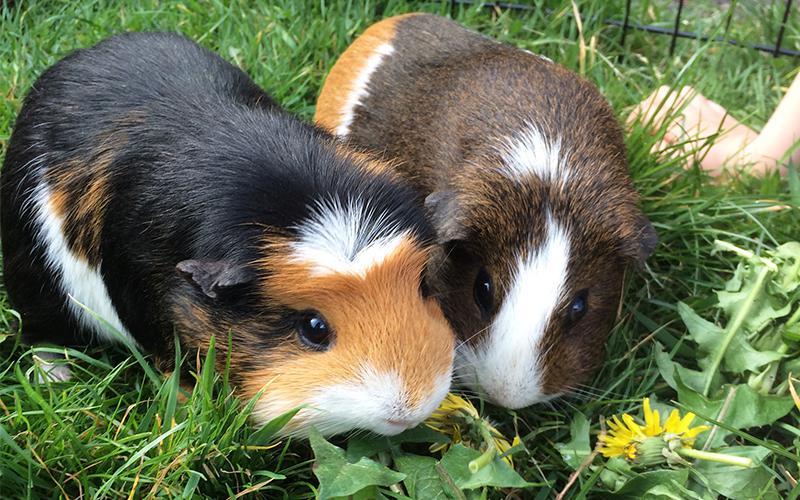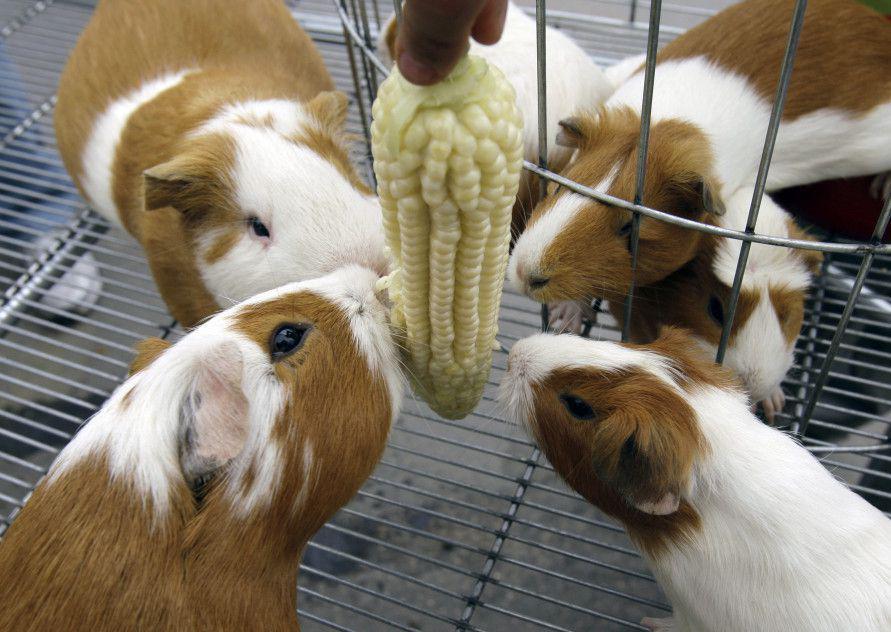The first image is the image on the left, the second image is the image on the right. Evaluate the accuracy of this statement regarding the images: "There are no more than four guinea pigs". Is it true? Answer yes or no. No. The first image is the image on the left, the second image is the image on the right. For the images shown, is this caption "There are at least six guinea pigs." true? Answer yes or no. Yes. 